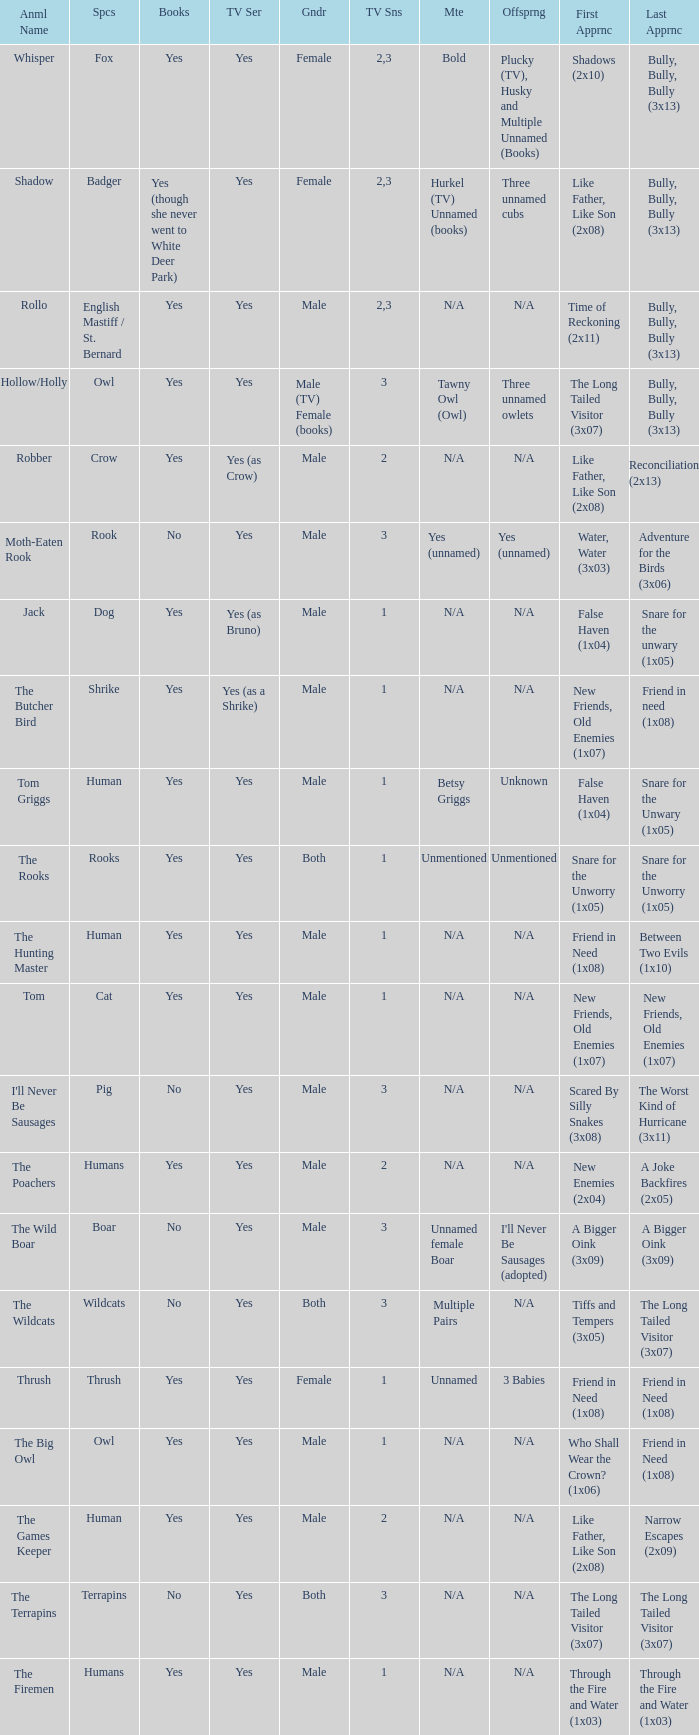What is the mate for Last Appearance of bully, bully, bully (3x13) for the animal named hollow/holly later than season 1? Tawny Owl (Owl). 